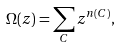<formula> <loc_0><loc_0><loc_500><loc_500>\Omega ( z ) = \sum _ { C } z ^ { n ( C ) } ,</formula> 